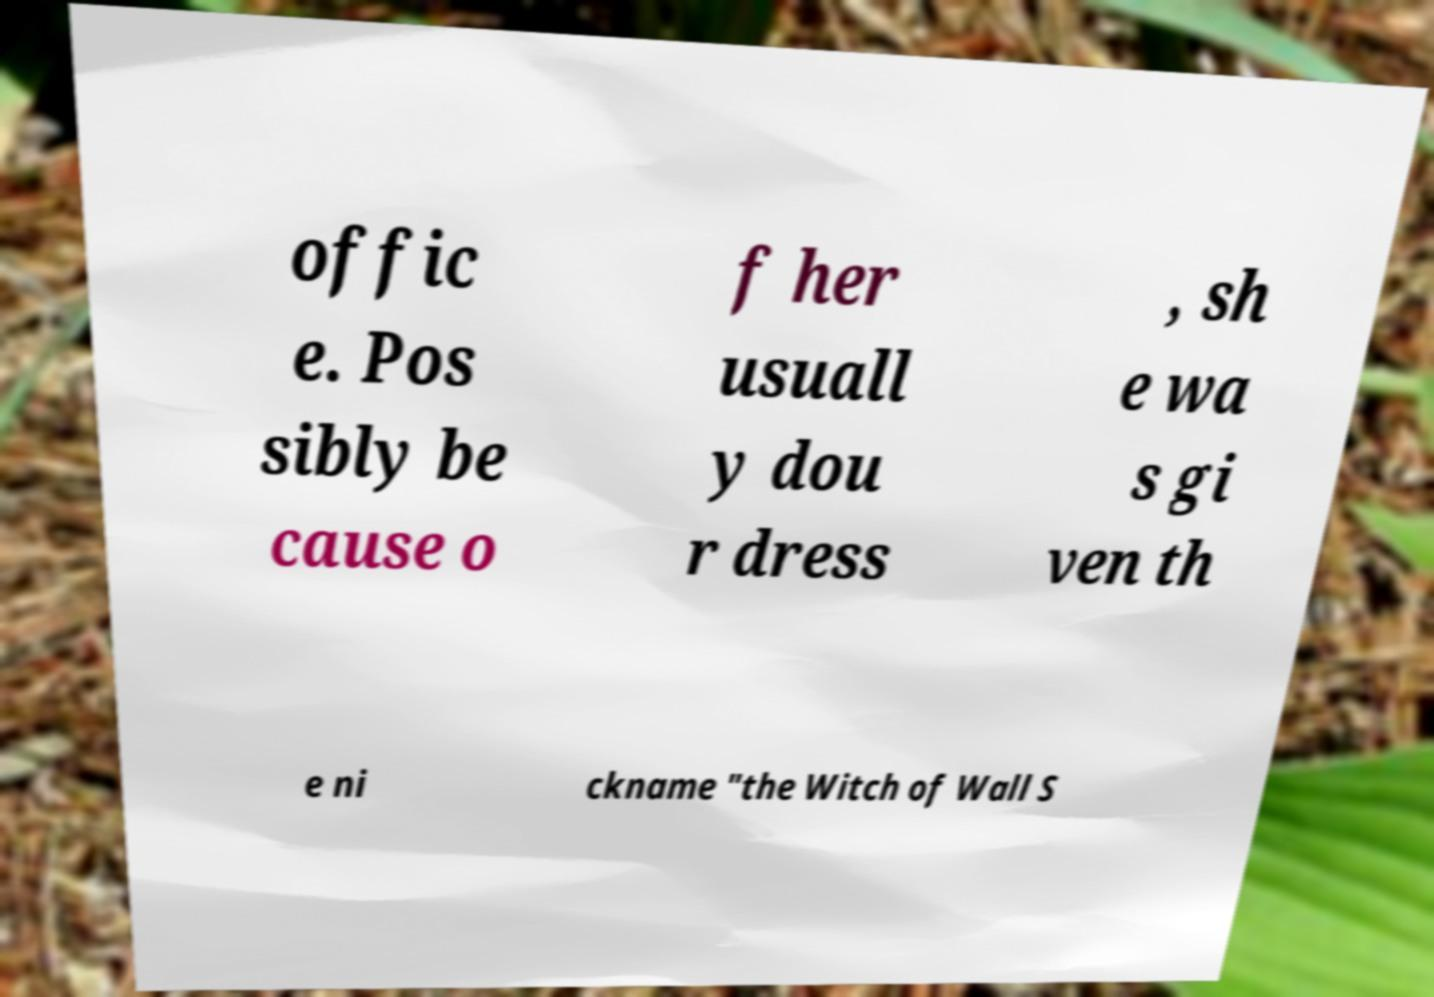What messages or text are displayed in this image? I need them in a readable, typed format. offic e. Pos sibly be cause o f her usuall y dou r dress , sh e wa s gi ven th e ni ckname "the Witch of Wall S 